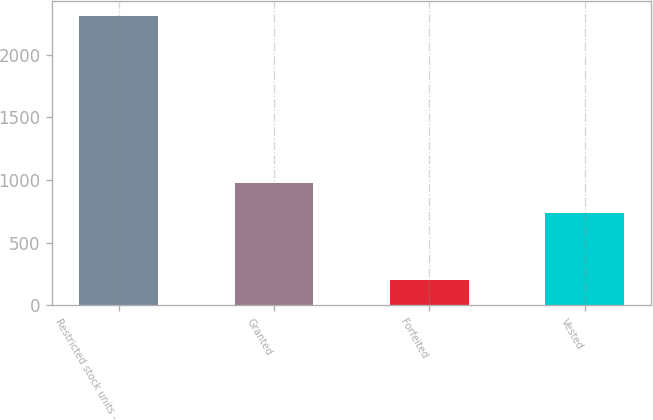<chart> <loc_0><loc_0><loc_500><loc_500><bar_chart><fcel>Restricted stock units -<fcel>Granted<fcel>Forfeited<fcel>Vested<nl><fcel>2315.3<fcel>977<fcel>204<fcel>736<nl></chart> 